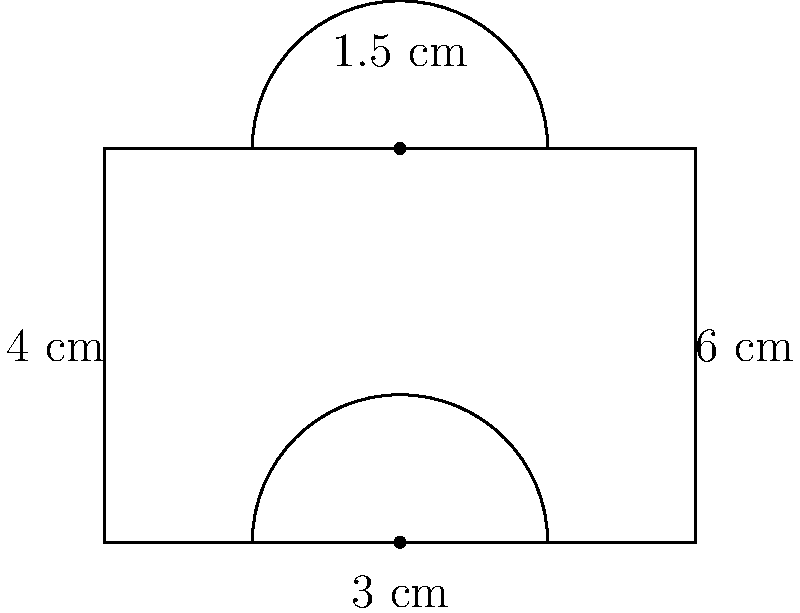An air filtration system has a cross-section as shown in the diagram. The shape consists of a rectangle with two semicircles on the top and bottom. If the width of the rectangle is 6 cm and its height is 4 cm, with the radius of each semicircle being 1.5 cm, calculate the total area of the cross-section in square centimeters. How might this shape affect the efficiency of air flow through the filtration system? Let's break this down step-by-step:

1) First, we need to calculate the area of the rectangle:
   $A_{rectangle} = width \times height = 6 \text{ cm} \times 4 \text{ cm} = 24 \text{ cm}^2$

2) Next, we need to calculate the area of each semicircle:
   $A_{semicircle} = \frac{1}{2} \times \pi r^2$
   $A_{semicircle} = \frac{1}{2} \times \pi \times (1.5 \text{ cm})^2$
   $A_{semicircle} = \frac{1}{2} \times \pi \times 2.25 \text{ cm}^2$
   $A_{semicircle} \approx 3.53 \text{ cm}^2$

3) There are two semicircles, so we multiply this by 2:
   $A_{total semicircles} = 2 \times 3.53 \text{ cm}^2 = 7.06 \text{ cm}^2$

4) The total area is the sum of the rectangle and the two semicircles:
   $A_{total} = A_{rectangle} + A_{total semicircles}$
   $A_{total} = 24 \text{ cm}^2 + 7.06 \text{ cm}^2 = 31.06 \text{ cm}^2$

Regarding efficiency, this shape could potentially improve air flow compared to a simple rectangle. The curved edges of the semicircles could help reduce turbulence and allow for smoother air flow through the system. This could potentially increase the efficiency of the filtration process by ensuring a more even distribution of air across the filter medium.
Answer: $31.06 \text{ cm}^2$ 